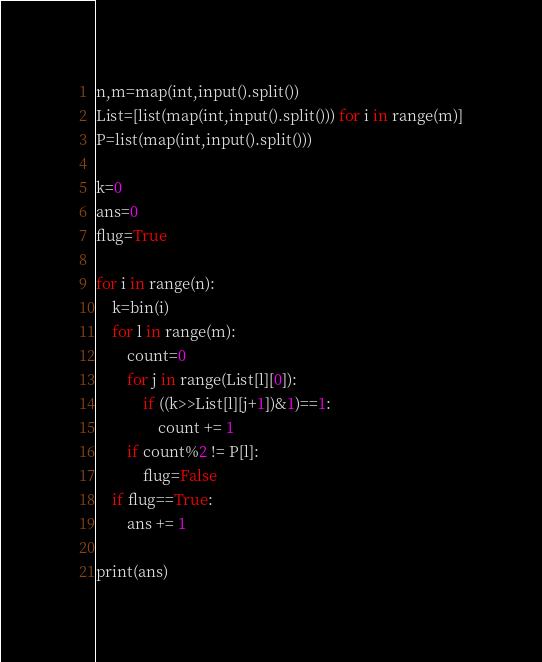<code> <loc_0><loc_0><loc_500><loc_500><_Python_>n,m=map(int,input().split())
List=[list(map(int,input().split())) for i in range(m)]
P=list(map(int,input().split()))

k=0
ans=0
flug=True

for i in range(n):
    k=bin(i)
    for l in range(m):
        count=0
        for j in range(List[l][0]):
            if ((k>>List[l][j+1])&1)==1:
                count += 1
        if count%2 != P[l]:
            flug=False
    if flug==True:
        ans += 1
        
print(ans)</code> 